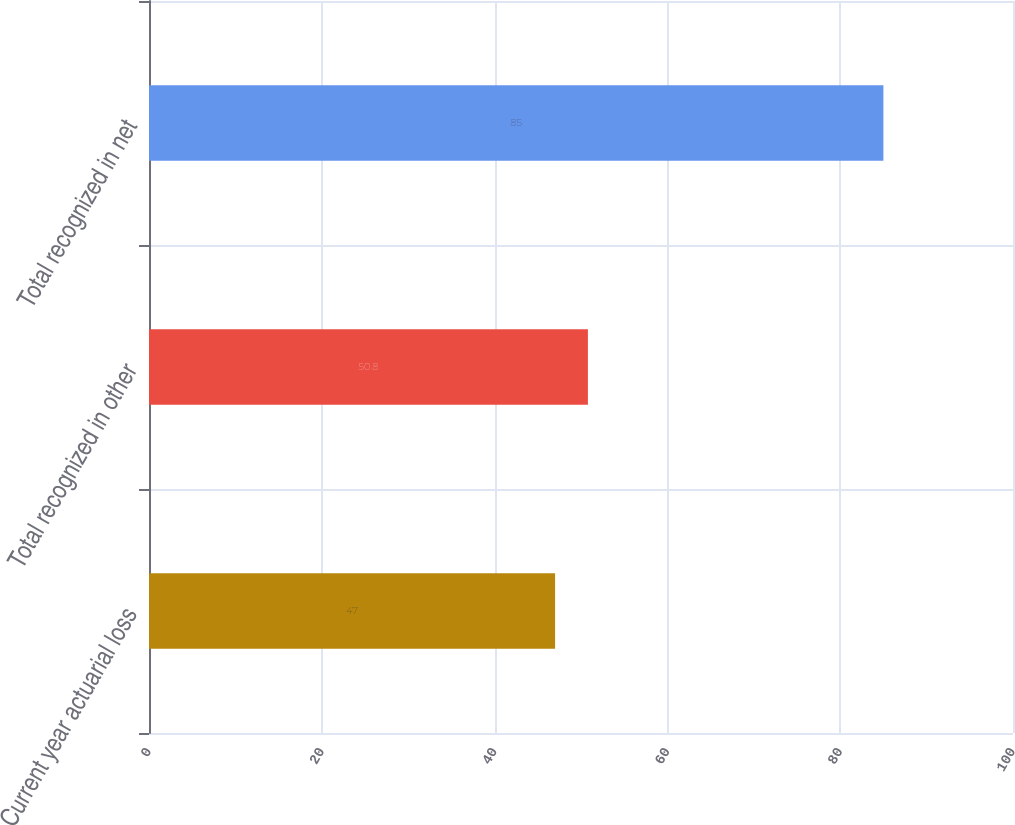<chart> <loc_0><loc_0><loc_500><loc_500><bar_chart><fcel>Current year actuarial loss<fcel>Total recognized in other<fcel>Total recognized in net<nl><fcel>47<fcel>50.8<fcel>85<nl></chart> 